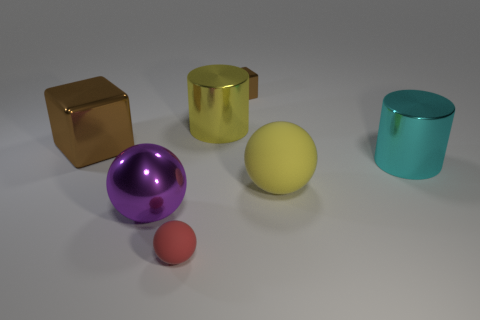There is a red thing that is the same shape as the big purple shiny thing; what is its size?
Keep it short and to the point. Small. There is another matte object that is the same shape as the small red rubber thing; what is its color?
Provide a succinct answer. Yellow. Does the big rubber object have the same shape as the small brown metal thing?
Give a very brief answer. No. Is the color of the large metallic thing in front of the large yellow rubber ball the same as the small matte ball?
Provide a short and direct response. No. How many large green metallic things have the same shape as the small brown object?
Provide a succinct answer. 0. Are there the same number of tiny objects that are in front of the large brown object and large purple cylinders?
Your answer should be very brief. No. What color is the thing that is the same size as the red sphere?
Give a very brief answer. Brown. Are there any gray rubber things that have the same shape as the big purple thing?
Keep it short and to the point. No. What material is the tiny thing behind the big shiny thing that is in front of the metallic thing that is on the right side of the tiny brown metallic block?
Your answer should be very brief. Metal. What number of other objects are the same size as the cyan object?
Offer a terse response. 4. 